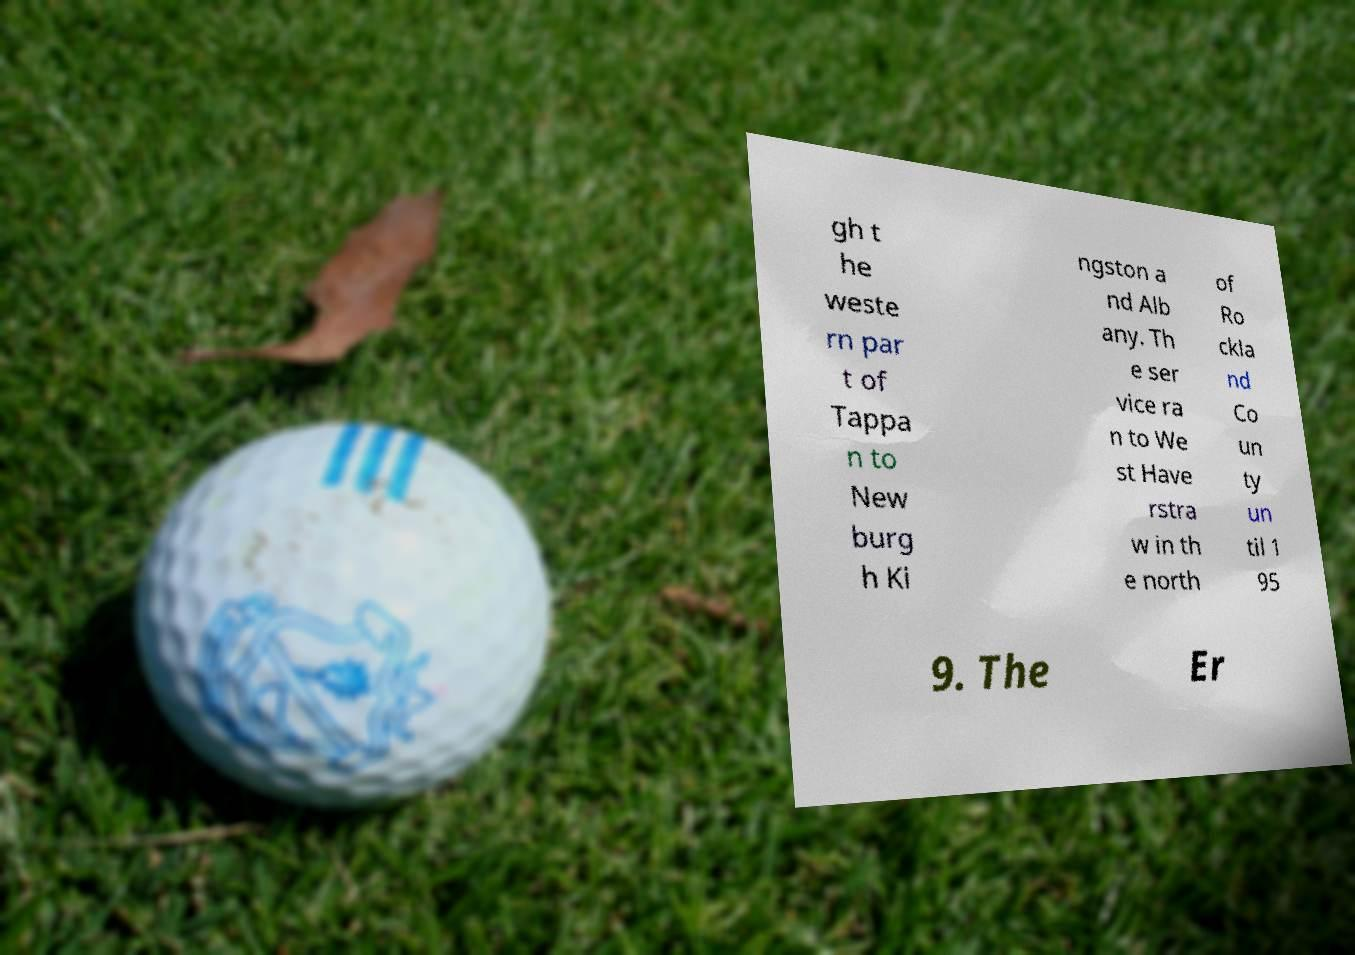Can you accurately transcribe the text from the provided image for me? gh t he weste rn par t of Tappa n to New burg h Ki ngston a nd Alb any. Th e ser vice ra n to We st Have rstra w in th e north of Ro ckla nd Co un ty un til 1 95 9. The Er 